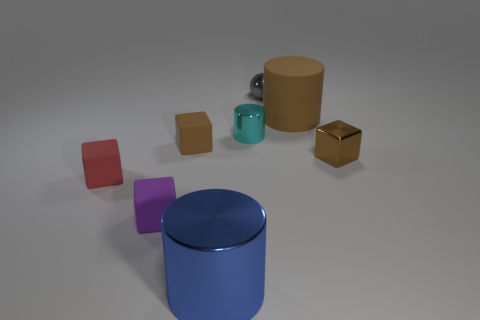There is another blue cylinder that is made of the same material as the small cylinder; what is its size?
Keep it short and to the point. Large. There is a metallic object that is in front of the tiny cylinder and left of the brown rubber cylinder; what size is it?
Offer a terse response. Large. There is a tiny matte thing that is behind the brown shiny cube; does it have the same color as the large cylinder that is behind the red cube?
Your answer should be compact. Yes. There is a small block that is to the left of the purple matte cube; what number of small cubes are to the right of it?
Offer a terse response. 3. How many metallic things are small purple things or blue cylinders?
Ensure brevity in your answer.  1. Are there any small brown objects made of the same material as the red object?
Provide a succinct answer. Yes. How many things are cylinders that are on the left side of the gray ball or small cubes that are left of the small purple rubber thing?
Provide a short and direct response. 3. There is a metal object behind the small cyan object; is it the same color as the big metal cylinder?
Provide a succinct answer. No. How many other things are there of the same color as the shiny cube?
Keep it short and to the point. 2. What material is the big blue object?
Provide a short and direct response. Metal. 